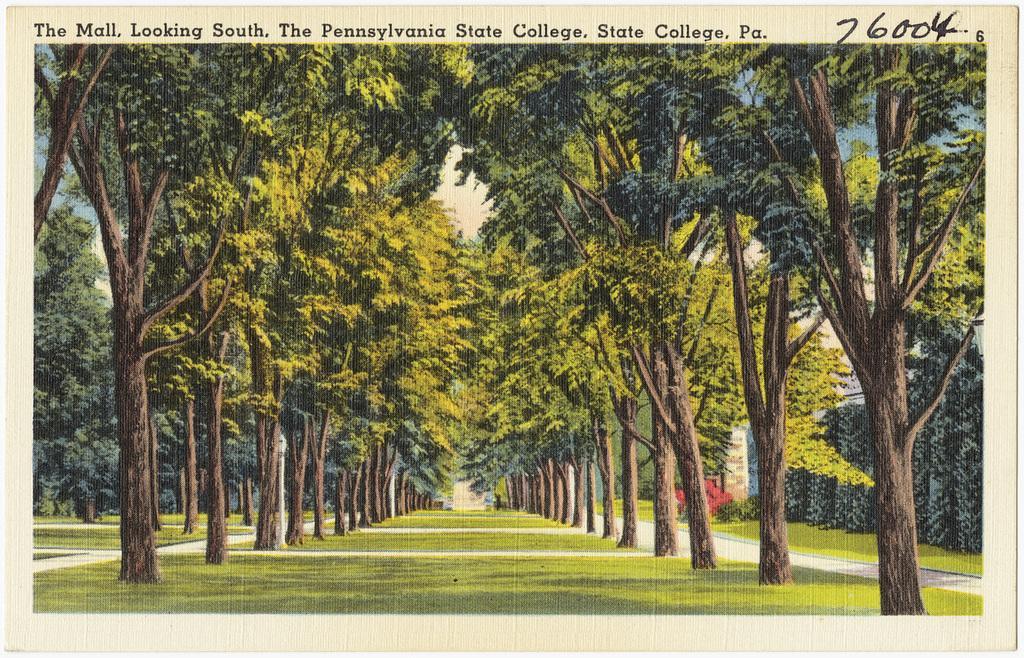Could you give a brief overview of what you see in this image? In this picture we can see a grassy ground with a walking path in between & surrounded by many trees. 